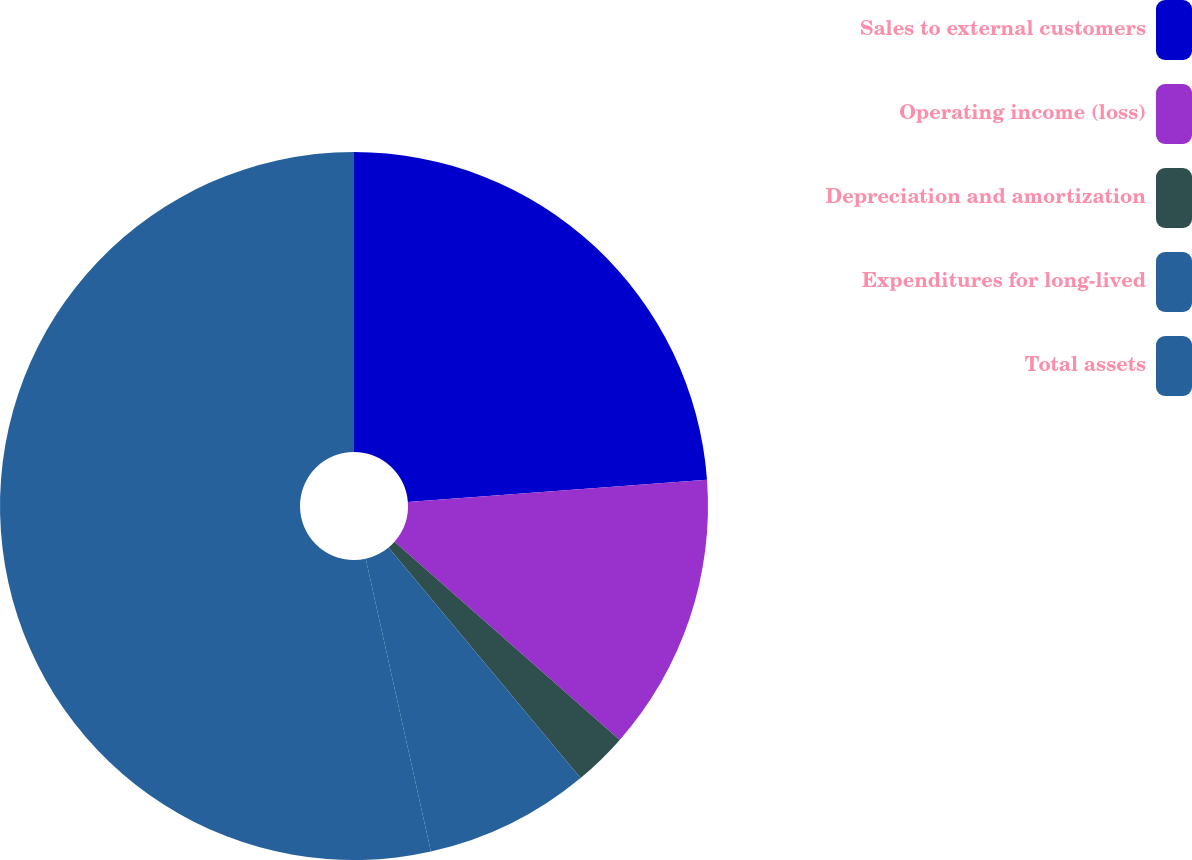<chart> <loc_0><loc_0><loc_500><loc_500><pie_chart><fcel>Sales to external customers<fcel>Operating income (loss)<fcel>Depreciation and amortization<fcel>Expenditures for long-lived<fcel>Total assets<nl><fcel>23.82%<fcel>12.67%<fcel>2.46%<fcel>7.57%<fcel>53.49%<nl></chart> 